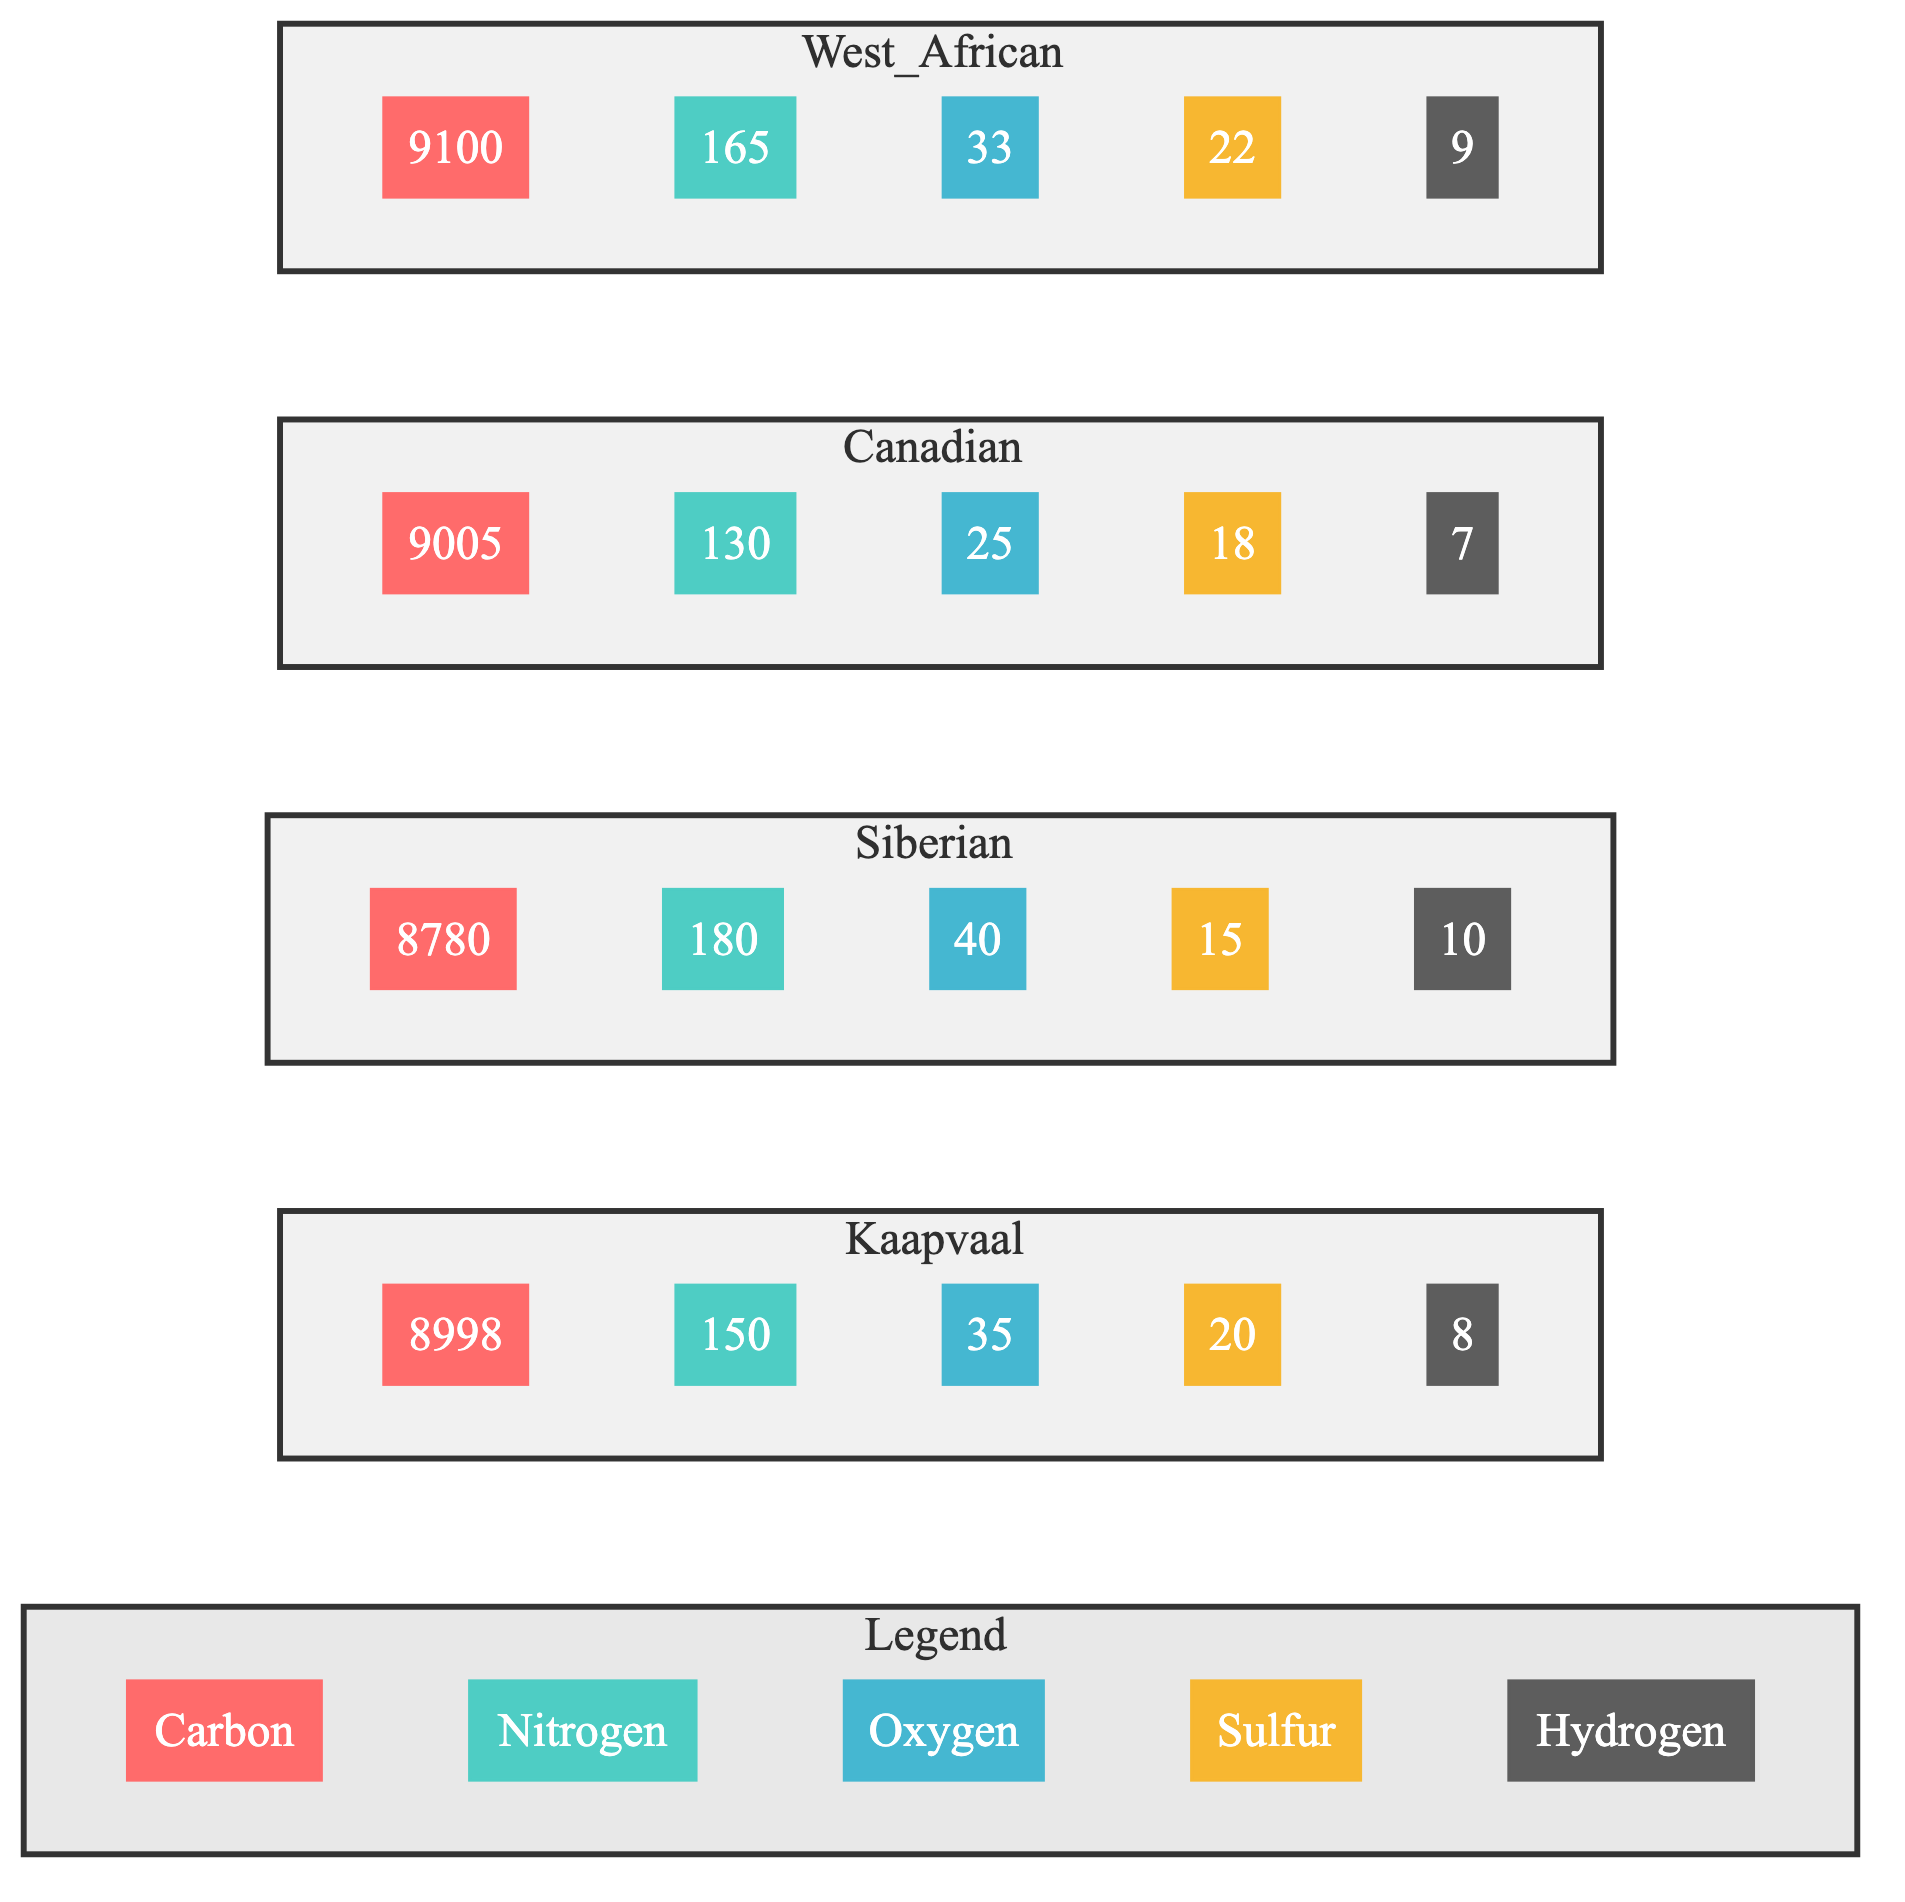What is the carbon content of the Kaapvaal province? The diagram shows the bar corresponding to the Kaapvaal province labeled "C" for Carbon. This bar indicates a value of 8998 for Carbon.
Answer: 8998 What is the nitrogen level in the Canadian diamond samples? Looking at the Canadian province's nitrogen bar labeled "N," we see it displays a value of 130.
Answer: 130 Which geological province has the highest sulfur content? To find the highest sulfur content, we compare the "S" values across all provinces. The highest value seen in the West African province is 22, more than the others.
Answer: West African How does the oxygen content in the Siberian diamonds compare to the Canadian diamonds? The diagram shows that Siberian diamonds have an oxygen content of 40 while Canadian diamonds have 25. So, Siberian diamonds have higher oxygen content by comparing these two values.
Answer: Higher What is the total sum of hydrogen content across all provinces? Hydrogen values from all provinces: Kaapvaal (8) + Siberian (10) + Canadian (7) + West African (9) gives a total of 34 after adding these four values together.
Answer: 34 Which province has the lowest carbon content? By inspecting the carbon values for each province, we find that the Siberian province has the lowest carbon content at 8780, making it the lowest among the four.
Answer: Siberian What relationship can be observed between carbon and nitrogen content in the Kaapvaal province? The Kaapvaal province shows a carbon content of 8998 and a nitrogen content of 150. This indicates a proportionally high carbon level compared to nitrogen, which is notably low in comparison.
Answer: High carbon, low nitrogen How many elements are represented in the diagram? The diagram presents five elements: Carbon, Nitrogen, Oxygen, Sulfur, and Hydrogen, which are listed in the Legend section. Counting these gives a total of five distinct elements.
Answer: 5 What is the oxygen content difference between the Kaapvaal and West African provinces? Kaapvaal has 35 for oxygen and West African has 33. The difference calculated by subtracting these values (35 - 33) indicates a difference of 2.
Answer: 2 